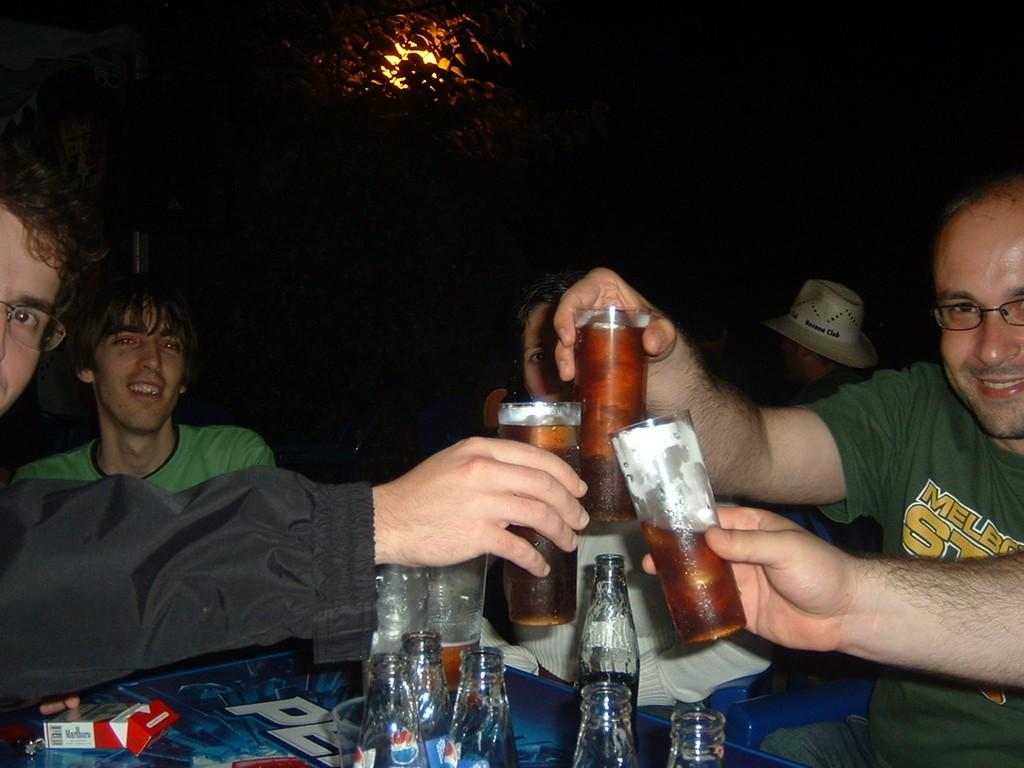Provide a one-sentence caption for the provided image. A pack of Marlboros is visible on top of the table. 